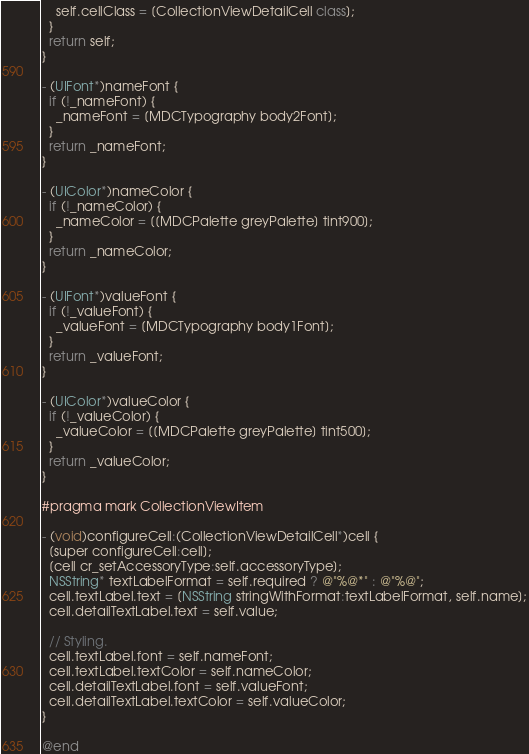<code> <loc_0><loc_0><loc_500><loc_500><_ObjectiveC_>    self.cellClass = [CollectionViewDetailCell class];
  }
  return self;
}

- (UIFont*)nameFont {
  if (!_nameFont) {
    _nameFont = [MDCTypography body2Font];
  }
  return _nameFont;
}

- (UIColor*)nameColor {
  if (!_nameColor) {
    _nameColor = [[MDCPalette greyPalette] tint900];
  }
  return _nameColor;
}

- (UIFont*)valueFont {
  if (!_valueFont) {
    _valueFont = [MDCTypography body1Font];
  }
  return _valueFont;
}

- (UIColor*)valueColor {
  if (!_valueColor) {
    _valueColor = [[MDCPalette greyPalette] tint500];
  }
  return _valueColor;
}

#pragma mark CollectionViewItem

- (void)configureCell:(CollectionViewDetailCell*)cell {
  [super configureCell:cell];
  [cell cr_setAccessoryType:self.accessoryType];
  NSString* textLabelFormat = self.required ? @"%@*" : @"%@";
  cell.textLabel.text = [NSString stringWithFormat:textLabelFormat, self.name];
  cell.detailTextLabel.text = self.value;

  // Styling.
  cell.textLabel.font = self.nameFont;
  cell.textLabel.textColor = self.nameColor;
  cell.detailTextLabel.font = self.valueFont;
  cell.detailTextLabel.textColor = self.valueColor;
}

@end
</code> 